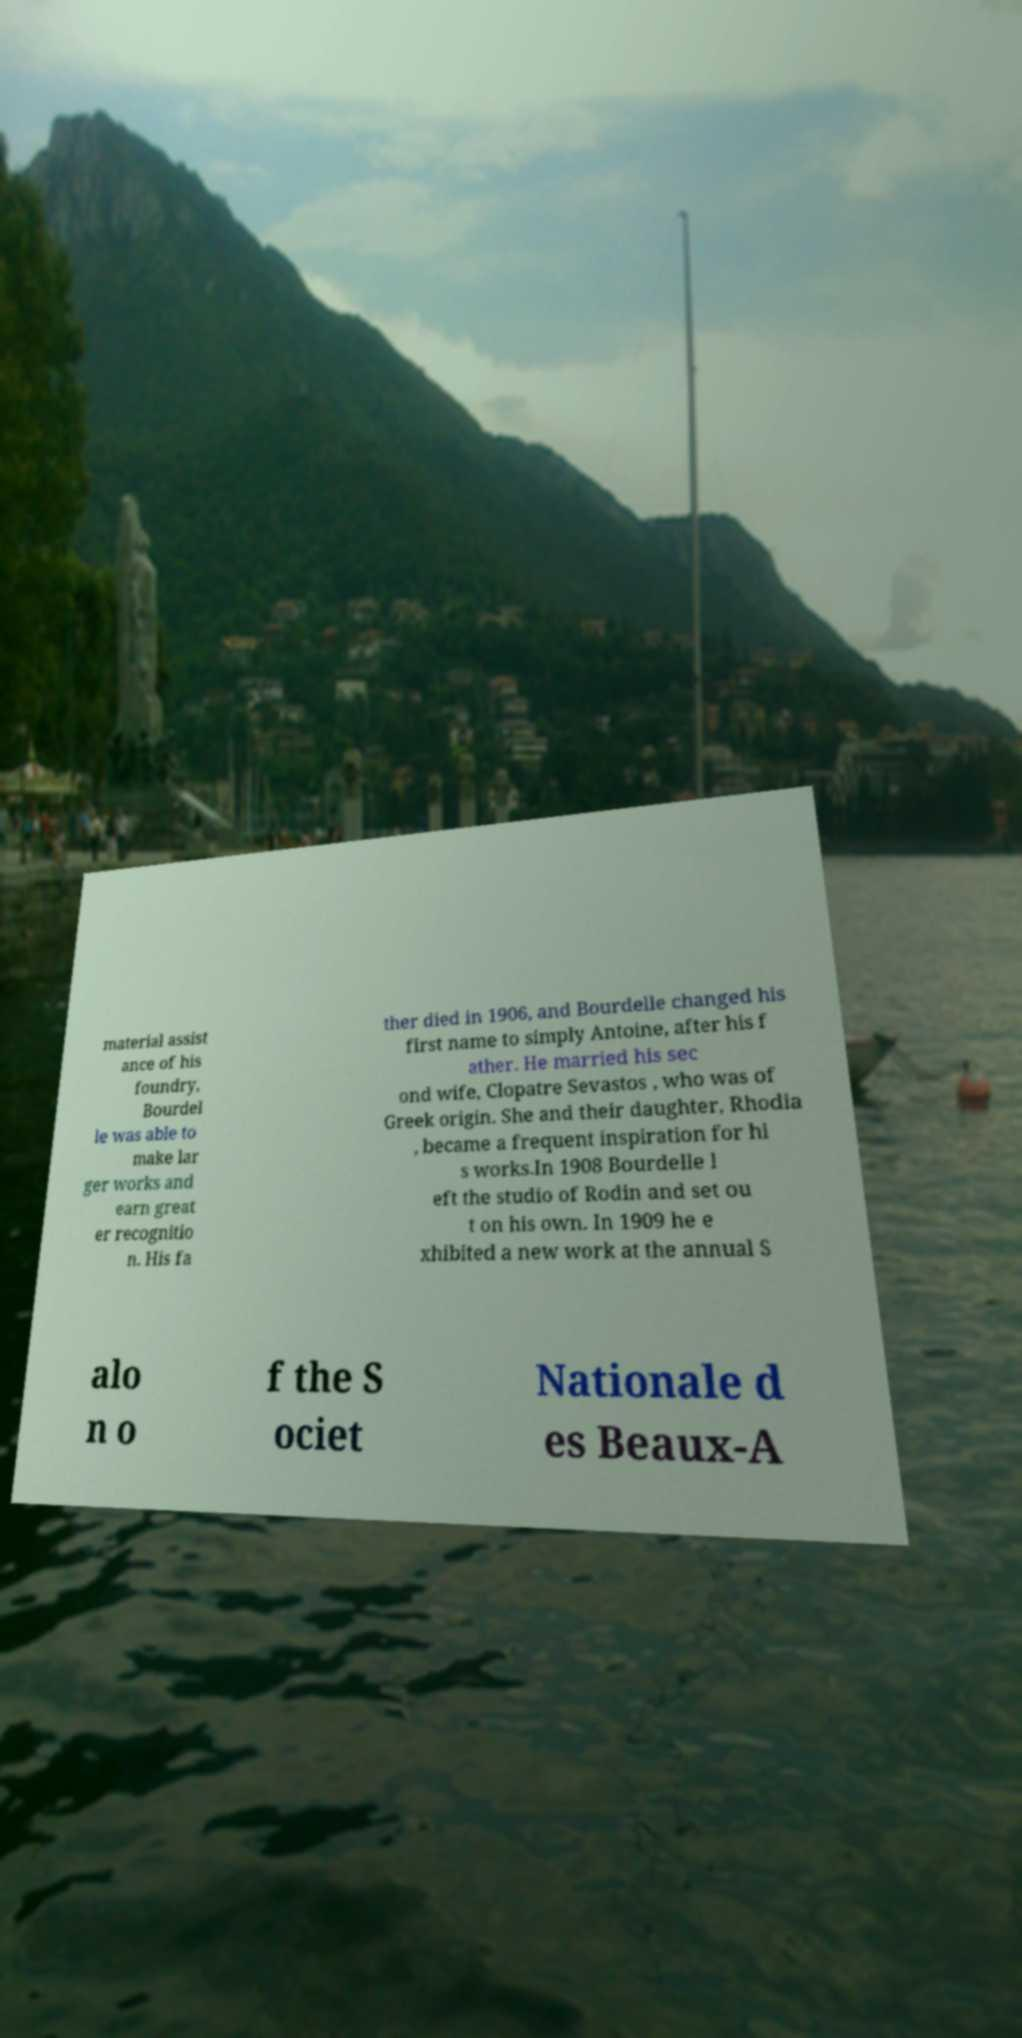Could you extract and type out the text from this image? material assist ance of his foundry, Bourdel le was able to make lar ger works and earn great er recognitio n. His fa ther died in 1906, and Bourdelle changed his first name to simply Antoine, after his f ather. He married his sec ond wife, Clopatre Sevastos , who was of Greek origin. She and their daughter, Rhodia , became a frequent inspiration for hi s works.In 1908 Bourdelle l eft the studio of Rodin and set ou t on his own. In 1909 he e xhibited a new work at the annual S alo n o f the S ociet Nationale d es Beaux-A 